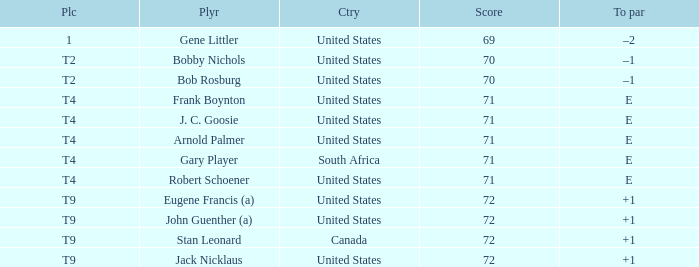What is Place, when Score is less than 70? 1.0. Could you help me parse every detail presented in this table? {'header': ['Plc', 'Plyr', 'Ctry', 'Score', 'To par'], 'rows': [['1', 'Gene Littler', 'United States', '69', '–2'], ['T2', 'Bobby Nichols', 'United States', '70', '–1'], ['T2', 'Bob Rosburg', 'United States', '70', '–1'], ['T4', 'Frank Boynton', 'United States', '71', 'E'], ['T4', 'J. C. Goosie', 'United States', '71', 'E'], ['T4', 'Arnold Palmer', 'United States', '71', 'E'], ['T4', 'Gary Player', 'South Africa', '71', 'E'], ['T4', 'Robert Schoener', 'United States', '71', 'E'], ['T9', 'Eugene Francis (a)', 'United States', '72', '+1'], ['T9', 'John Guenther (a)', 'United States', '72', '+1'], ['T9', 'Stan Leonard', 'Canada', '72', '+1'], ['T9', 'Jack Nicklaus', 'United States', '72', '+1']]} 